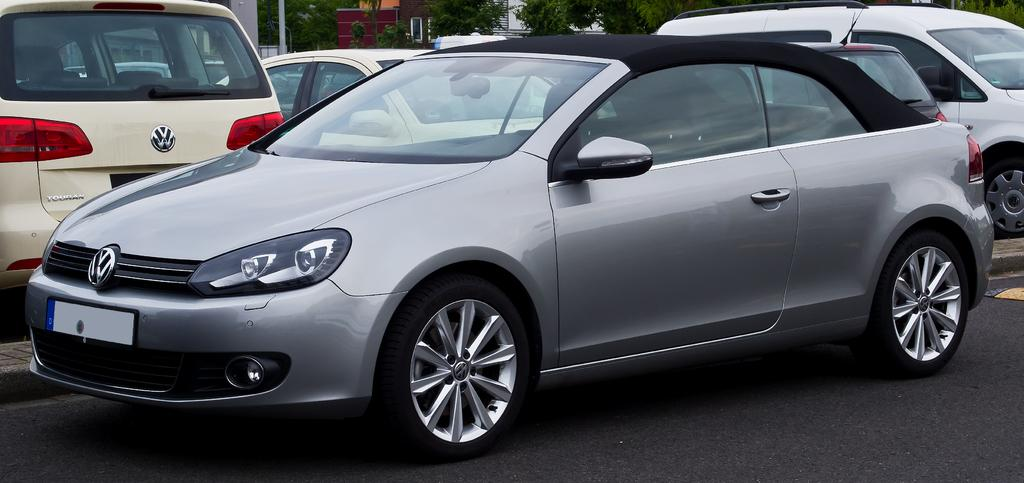What types of objects can be seen in the image? There are vehicles in the image. What can be seen in the distance behind the vehicles? There are buildings and trees in the background of the image. What color is the brain of the person driving the vehicle in the image? There is no person or brain visible in the image; it only shows vehicles, buildings, and trees. 